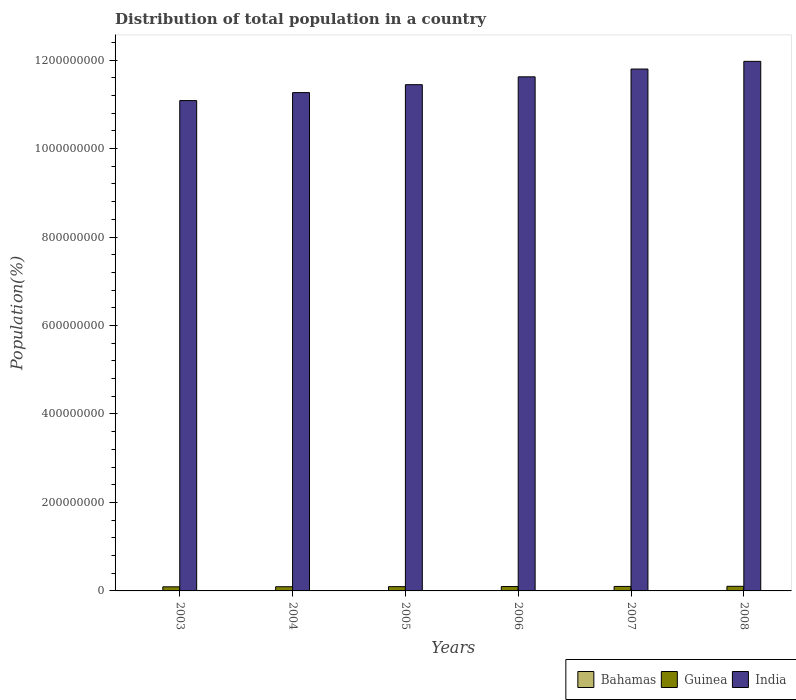How many groups of bars are there?
Your answer should be very brief. 6. Are the number of bars per tick equal to the number of legend labels?
Your answer should be very brief. Yes. How many bars are there on the 3rd tick from the right?
Your answer should be compact. 3. What is the label of the 2nd group of bars from the left?
Provide a short and direct response. 2004. In how many cases, is the number of bars for a given year not equal to the number of legend labels?
Your answer should be compact. 0. What is the population of in Guinea in 2003?
Ensure brevity in your answer.  9.28e+06. Across all years, what is the maximum population of in India?
Your response must be concise. 1.20e+09. Across all years, what is the minimum population of in Guinea?
Provide a short and direct response. 9.28e+06. What is the total population of in Guinea in the graph?
Offer a very short reply. 5.89e+07. What is the difference between the population of in Guinea in 2006 and that in 2007?
Offer a very short reply. -2.54e+05. What is the difference between the population of in India in 2007 and the population of in Bahamas in 2006?
Your answer should be compact. 1.18e+09. What is the average population of in Guinea per year?
Provide a succinct answer. 9.82e+06. In the year 2003, what is the difference between the population of in India and population of in Bahamas?
Your response must be concise. 1.11e+09. In how many years, is the population of in Guinea greater than 320000000 %?
Your response must be concise. 0. What is the ratio of the population of in Guinea in 2006 to that in 2008?
Offer a terse response. 0.95. Is the difference between the population of in India in 2003 and 2006 greater than the difference between the population of in Bahamas in 2003 and 2006?
Give a very brief answer. No. What is the difference between the highest and the second highest population of in Guinea?
Keep it short and to the point. 2.75e+05. What is the difference between the highest and the lowest population of in India?
Give a very brief answer. 8.87e+07. In how many years, is the population of in India greater than the average population of in India taken over all years?
Keep it short and to the point. 3. What does the 3rd bar from the left in 2007 represents?
Provide a short and direct response. India. Is it the case that in every year, the sum of the population of in Bahamas and population of in Guinea is greater than the population of in India?
Keep it short and to the point. No. What is the difference between two consecutive major ticks on the Y-axis?
Make the answer very short. 2.00e+08. Where does the legend appear in the graph?
Make the answer very short. Bottom right. What is the title of the graph?
Your response must be concise. Distribution of total population in a country. What is the label or title of the Y-axis?
Your answer should be very brief. Population(%). What is the Population(%) in Bahamas in 2003?
Your answer should be very brief. 3.16e+05. What is the Population(%) of Guinea in 2003?
Keep it short and to the point. 9.28e+06. What is the Population(%) of India in 2003?
Ensure brevity in your answer.  1.11e+09. What is the Population(%) in Bahamas in 2004?
Your answer should be compact. 3.23e+05. What is the Population(%) of Guinea in 2004?
Offer a very short reply. 9.46e+06. What is the Population(%) of India in 2004?
Make the answer very short. 1.13e+09. What is the Population(%) of Bahamas in 2005?
Ensure brevity in your answer.  3.29e+05. What is the Population(%) in Guinea in 2005?
Provide a short and direct response. 9.67e+06. What is the Population(%) of India in 2005?
Keep it short and to the point. 1.14e+09. What is the Population(%) in Bahamas in 2006?
Provide a succinct answer. 3.36e+05. What is the Population(%) of Guinea in 2006?
Your response must be concise. 9.90e+06. What is the Population(%) of India in 2006?
Offer a very short reply. 1.16e+09. What is the Population(%) in Bahamas in 2007?
Ensure brevity in your answer.  3.42e+05. What is the Population(%) in Guinea in 2007?
Provide a short and direct response. 1.02e+07. What is the Population(%) of India in 2007?
Your answer should be compact. 1.18e+09. What is the Population(%) of Bahamas in 2008?
Your answer should be compact. 3.49e+05. What is the Population(%) of Guinea in 2008?
Keep it short and to the point. 1.04e+07. What is the Population(%) of India in 2008?
Make the answer very short. 1.20e+09. Across all years, what is the maximum Population(%) of Bahamas?
Offer a very short reply. 3.49e+05. Across all years, what is the maximum Population(%) in Guinea?
Offer a very short reply. 1.04e+07. Across all years, what is the maximum Population(%) of India?
Make the answer very short. 1.20e+09. Across all years, what is the minimum Population(%) of Bahamas?
Make the answer very short. 3.16e+05. Across all years, what is the minimum Population(%) in Guinea?
Give a very brief answer. 9.28e+06. Across all years, what is the minimum Population(%) in India?
Your response must be concise. 1.11e+09. What is the total Population(%) in Bahamas in the graph?
Your answer should be compact. 1.99e+06. What is the total Population(%) of Guinea in the graph?
Your answer should be compact. 5.89e+07. What is the total Population(%) in India in the graph?
Make the answer very short. 6.92e+09. What is the difference between the Population(%) of Bahamas in 2003 and that in 2004?
Your answer should be compact. -6782. What is the difference between the Population(%) of Guinea in 2003 and that in 2004?
Your answer should be compact. -1.83e+05. What is the difference between the Population(%) of India in 2003 and that in 2004?
Your answer should be compact. -1.80e+07. What is the difference between the Population(%) in Bahamas in 2003 and that in 2005?
Provide a short and direct response. -1.35e+04. What is the difference between the Population(%) in Guinea in 2003 and that in 2005?
Provide a short and direct response. -3.87e+05. What is the difference between the Population(%) of India in 2003 and that in 2005?
Offer a terse response. -3.60e+07. What is the difference between the Population(%) in Bahamas in 2003 and that in 2006?
Keep it short and to the point. -2.00e+04. What is the difference between the Population(%) of Guinea in 2003 and that in 2006?
Keep it short and to the point. -6.17e+05. What is the difference between the Population(%) in India in 2003 and that in 2006?
Your response must be concise. -5.37e+07. What is the difference between the Population(%) of Bahamas in 2003 and that in 2007?
Make the answer very short. -2.65e+04. What is the difference between the Population(%) in Guinea in 2003 and that in 2007?
Your response must be concise. -8.71e+05. What is the difference between the Population(%) of India in 2003 and that in 2007?
Provide a short and direct response. -7.13e+07. What is the difference between the Population(%) of Bahamas in 2003 and that in 2008?
Your answer should be compact. -3.28e+04. What is the difference between the Population(%) in Guinea in 2003 and that in 2008?
Your answer should be compact. -1.15e+06. What is the difference between the Population(%) of India in 2003 and that in 2008?
Make the answer very short. -8.87e+07. What is the difference between the Population(%) in Bahamas in 2004 and that in 2005?
Offer a terse response. -6704. What is the difference between the Population(%) of Guinea in 2004 and that in 2005?
Offer a terse response. -2.04e+05. What is the difference between the Population(%) in India in 2004 and that in 2005?
Your answer should be compact. -1.79e+07. What is the difference between the Population(%) of Bahamas in 2004 and that in 2006?
Provide a succinct answer. -1.33e+04. What is the difference between the Population(%) of Guinea in 2004 and that in 2006?
Your answer should be very brief. -4.34e+05. What is the difference between the Population(%) of India in 2004 and that in 2006?
Give a very brief answer. -3.57e+07. What is the difference between the Population(%) of Bahamas in 2004 and that in 2007?
Your response must be concise. -1.97e+04. What is the difference between the Population(%) in Guinea in 2004 and that in 2007?
Your response must be concise. -6.88e+05. What is the difference between the Population(%) in India in 2004 and that in 2007?
Ensure brevity in your answer.  -5.33e+07. What is the difference between the Population(%) of Bahamas in 2004 and that in 2008?
Provide a succinct answer. -2.60e+04. What is the difference between the Population(%) of Guinea in 2004 and that in 2008?
Ensure brevity in your answer.  -9.63e+05. What is the difference between the Population(%) in India in 2004 and that in 2008?
Your answer should be compact. -7.07e+07. What is the difference between the Population(%) of Bahamas in 2005 and that in 2006?
Make the answer very short. -6558. What is the difference between the Population(%) of Guinea in 2005 and that in 2006?
Offer a very short reply. -2.29e+05. What is the difference between the Population(%) in India in 2005 and that in 2006?
Ensure brevity in your answer.  -1.78e+07. What is the difference between the Population(%) in Bahamas in 2005 and that in 2007?
Your answer should be very brief. -1.30e+04. What is the difference between the Population(%) in Guinea in 2005 and that in 2007?
Offer a very short reply. -4.83e+05. What is the difference between the Population(%) of India in 2005 and that in 2007?
Provide a succinct answer. -3.54e+07. What is the difference between the Population(%) of Bahamas in 2005 and that in 2008?
Your response must be concise. -1.93e+04. What is the difference between the Population(%) of Guinea in 2005 and that in 2008?
Your answer should be compact. -7.58e+05. What is the difference between the Population(%) of India in 2005 and that in 2008?
Give a very brief answer. -5.27e+07. What is the difference between the Population(%) in Bahamas in 2006 and that in 2007?
Offer a very short reply. -6458. What is the difference between the Population(%) in Guinea in 2006 and that in 2007?
Make the answer very short. -2.54e+05. What is the difference between the Population(%) in India in 2006 and that in 2007?
Offer a terse response. -1.76e+07. What is the difference between the Population(%) in Bahamas in 2006 and that in 2008?
Provide a short and direct response. -1.28e+04. What is the difference between the Population(%) of Guinea in 2006 and that in 2008?
Your answer should be very brief. -5.29e+05. What is the difference between the Population(%) of India in 2006 and that in 2008?
Give a very brief answer. -3.50e+07. What is the difference between the Population(%) in Bahamas in 2007 and that in 2008?
Ensure brevity in your answer.  -6328. What is the difference between the Population(%) in Guinea in 2007 and that in 2008?
Your answer should be compact. -2.75e+05. What is the difference between the Population(%) in India in 2007 and that in 2008?
Your response must be concise. -1.74e+07. What is the difference between the Population(%) of Bahamas in 2003 and the Population(%) of Guinea in 2004?
Offer a terse response. -9.15e+06. What is the difference between the Population(%) in Bahamas in 2003 and the Population(%) in India in 2004?
Ensure brevity in your answer.  -1.13e+09. What is the difference between the Population(%) in Guinea in 2003 and the Population(%) in India in 2004?
Give a very brief answer. -1.12e+09. What is the difference between the Population(%) in Bahamas in 2003 and the Population(%) in Guinea in 2005?
Ensure brevity in your answer.  -9.35e+06. What is the difference between the Population(%) in Bahamas in 2003 and the Population(%) in India in 2005?
Your response must be concise. -1.14e+09. What is the difference between the Population(%) in Guinea in 2003 and the Population(%) in India in 2005?
Offer a terse response. -1.14e+09. What is the difference between the Population(%) in Bahamas in 2003 and the Population(%) in Guinea in 2006?
Your response must be concise. -9.58e+06. What is the difference between the Population(%) of Bahamas in 2003 and the Population(%) of India in 2006?
Give a very brief answer. -1.16e+09. What is the difference between the Population(%) of Guinea in 2003 and the Population(%) of India in 2006?
Your answer should be very brief. -1.15e+09. What is the difference between the Population(%) in Bahamas in 2003 and the Population(%) in Guinea in 2007?
Your response must be concise. -9.84e+06. What is the difference between the Population(%) of Bahamas in 2003 and the Population(%) of India in 2007?
Make the answer very short. -1.18e+09. What is the difference between the Population(%) in Guinea in 2003 and the Population(%) in India in 2007?
Offer a terse response. -1.17e+09. What is the difference between the Population(%) of Bahamas in 2003 and the Population(%) of Guinea in 2008?
Your answer should be very brief. -1.01e+07. What is the difference between the Population(%) of Bahamas in 2003 and the Population(%) of India in 2008?
Give a very brief answer. -1.20e+09. What is the difference between the Population(%) in Guinea in 2003 and the Population(%) in India in 2008?
Your answer should be very brief. -1.19e+09. What is the difference between the Population(%) in Bahamas in 2004 and the Population(%) in Guinea in 2005?
Your response must be concise. -9.35e+06. What is the difference between the Population(%) in Bahamas in 2004 and the Population(%) in India in 2005?
Provide a short and direct response. -1.14e+09. What is the difference between the Population(%) of Guinea in 2004 and the Population(%) of India in 2005?
Provide a short and direct response. -1.13e+09. What is the difference between the Population(%) in Bahamas in 2004 and the Population(%) in Guinea in 2006?
Make the answer very short. -9.58e+06. What is the difference between the Population(%) of Bahamas in 2004 and the Population(%) of India in 2006?
Keep it short and to the point. -1.16e+09. What is the difference between the Population(%) of Guinea in 2004 and the Population(%) of India in 2006?
Provide a succinct answer. -1.15e+09. What is the difference between the Population(%) of Bahamas in 2004 and the Population(%) of Guinea in 2007?
Keep it short and to the point. -9.83e+06. What is the difference between the Population(%) of Bahamas in 2004 and the Population(%) of India in 2007?
Provide a short and direct response. -1.18e+09. What is the difference between the Population(%) in Guinea in 2004 and the Population(%) in India in 2007?
Your response must be concise. -1.17e+09. What is the difference between the Population(%) of Bahamas in 2004 and the Population(%) of Guinea in 2008?
Make the answer very short. -1.01e+07. What is the difference between the Population(%) in Bahamas in 2004 and the Population(%) in India in 2008?
Make the answer very short. -1.20e+09. What is the difference between the Population(%) of Guinea in 2004 and the Population(%) of India in 2008?
Keep it short and to the point. -1.19e+09. What is the difference between the Population(%) of Bahamas in 2005 and the Population(%) of Guinea in 2006?
Your answer should be compact. -9.57e+06. What is the difference between the Population(%) in Bahamas in 2005 and the Population(%) in India in 2006?
Ensure brevity in your answer.  -1.16e+09. What is the difference between the Population(%) in Guinea in 2005 and the Population(%) in India in 2006?
Your response must be concise. -1.15e+09. What is the difference between the Population(%) of Bahamas in 2005 and the Population(%) of Guinea in 2007?
Give a very brief answer. -9.82e+06. What is the difference between the Population(%) in Bahamas in 2005 and the Population(%) in India in 2007?
Provide a succinct answer. -1.18e+09. What is the difference between the Population(%) in Guinea in 2005 and the Population(%) in India in 2007?
Your answer should be very brief. -1.17e+09. What is the difference between the Population(%) of Bahamas in 2005 and the Population(%) of Guinea in 2008?
Your answer should be very brief. -1.01e+07. What is the difference between the Population(%) in Bahamas in 2005 and the Population(%) in India in 2008?
Your answer should be compact. -1.20e+09. What is the difference between the Population(%) of Guinea in 2005 and the Population(%) of India in 2008?
Provide a succinct answer. -1.19e+09. What is the difference between the Population(%) of Bahamas in 2006 and the Population(%) of Guinea in 2007?
Provide a short and direct response. -9.82e+06. What is the difference between the Population(%) of Bahamas in 2006 and the Population(%) of India in 2007?
Make the answer very short. -1.18e+09. What is the difference between the Population(%) of Guinea in 2006 and the Population(%) of India in 2007?
Your answer should be very brief. -1.17e+09. What is the difference between the Population(%) in Bahamas in 2006 and the Population(%) in Guinea in 2008?
Offer a terse response. -1.01e+07. What is the difference between the Population(%) of Bahamas in 2006 and the Population(%) of India in 2008?
Your response must be concise. -1.20e+09. What is the difference between the Population(%) of Guinea in 2006 and the Population(%) of India in 2008?
Your answer should be very brief. -1.19e+09. What is the difference between the Population(%) in Bahamas in 2007 and the Population(%) in Guinea in 2008?
Offer a very short reply. -1.01e+07. What is the difference between the Population(%) in Bahamas in 2007 and the Population(%) in India in 2008?
Give a very brief answer. -1.20e+09. What is the difference between the Population(%) in Guinea in 2007 and the Population(%) in India in 2008?
Give a very brief answer. -1.19e+09. What is the average Population(%) in Bahamas per year?
Your response must be concise. 3.32e+05. What is the average Population(%) in Guinea per year?
Provide a succinct answer. 9.82e+06. What is the average Population(%) of India per year?
Your answer should be very brief. 1.15e+09. In the year 2003, what is the difference between the Population(%) of Bahamas and Population(%) of Guinea?
Your response must be concise. -8.97e+06. In the year 2003, what is the difference between the Population(%) in Bahamas and Population(%) in India?
Keep it short and to the point. -1.11e+09. In the year 2003, what is the difference between the Population(%) of Guinea and Population(%) of India?
Offer a terse response. -1.10e+09. In the year 2004, what is the difference between the Population(%) in Bahamas and Population(%) in Guinea?
Make the answer very short. -9.14e+06. In the year 2004, what is the difference between the Population(%) of Bahamas and Population(%) of India?
Your answer should be compact. -1.13e+09. In the year 2004, what is the difference between the Population(%) of Guinea and Population(%) of India?
Make the answer very short. -1.12e+09. In the year 2005, what is the difference between the Population(%) in Bahamas and Population(%) in Guinea?
Your response must be concise. -9.34e+06. In the year 2005, what is the difference between the Population(%) of Bahamas and Population(%) of India?
Offer a very short reply. -1.14e+09. In the year 2005, what is the difference between the Population(%) in Guinea and Population(%) in India?
Keep it short and to the point. -1.13e+09. In the year 2006, what is the difference between the Population(%) of Bahamas and Population(%) of Guinea?
Your answer should be compact. -9.56e+06. In the year 2006, what is the difference between the Population(%) in Bahamas and Population(%) in India?
Offer a very short reply. -1.16e+09. In the year 2006, what is the difference between the Population(%) of Guinea and Population(%) of India?
Your answer should be very brief. -1.15e+09. In the year 2007, what is the difference between the Population(%) in Bahamas and Population(%) in Guinea?
Make the answer very short. -9.81e+06. In the year 2007, what is the difference between the Population(%) of Bahamas and Population(%) of India?
Provide a succinct answer. -1.18e+09. In the year 2007, what is the difference between the Population(%) in Guinea and Population(%) in India?
Your answer should be compact. -1.17e+09. In the year 2008, what is the difference between the Population(%) in Bahamas and Population(%) in Guinea?
Your answer should be compact. -1.01e+07. In the year 2008, what is the difference between the Population(%) in Bahamas and Population(%) in India?
Give a very brief answer. -1.20e+09. In the year 2008, what is the difference between the Population(%) of Guinea and Population(%) of India?
Provide a succinct answer. -1.19e+09. What is the ratio of the Population(%) of Bahamas in 2003 to that in 2004?
Your response must be concise. 0.98. What is the ratio of the Population(%) of Guinea in 2003 to that in 2004?
Give a very brief answer. 0.98. What is the ratio of the Population(%) in India in 2003 to that in 2004?
Give a very brief answer. 0.98. What is the ratio of the Population(%) in Guinea in 2003 to that in 2005?
Make the answer very short. 0.96. What is the ratio of the Population(%) in India in 2003 to that in 2005?
Provide a succinct answer. 0.97. What is the ratio of the Population(%) in Bahamas in 2003 to that in 2006?
Provide a short and direct response. 0.94. What is the ratio of the Population(%) of Guinea in 2003 to that in 2006?
Make the answer very short. 0.94. What is the ratio of the Population(%) of India in 2003 to that in 2006?
Offer a terse response. 0.95. What is the ratio of the Population(%) of Bahamas in 2003 to that in 2007?
Your response must be concise. 0.92. What is the ratio of the Population(%) of Guinea in 2003 to that in 2007?
Your answer should be compact. 0.91. What is the ratio of the Population(%) in India in 2003 to that in 2007?
Give a very brief answer. 0.94. What is the ratio of the Population(%) of Bahamas in 2003 to that in 2008?
Your response must be concise. 0.91. What is the ratio of the Population(%) of Guinea in 2003 to that in 2008?
Ensure brevity in your answer.  0.89. What is the ratio of the Population(%) of India in 2003 to that in 2008?
Offer a terse response. 0.93. What is the ratio of the Population(%) in Bahamas in 2004 to that in 2005?
Offer a terse response. 0.98. What is the ratio of the Population(%) in Guinea in 2004 to that in 2005?
Provide a short and direct response. 0.98. What is the ratio of the Population(%) of India in 2004 to that in 2005?
Make the answer very short. 0.98. What is the ratio of the Population(%) of Bahamas in 2004 to that in 2006?
Your answer should be compact. 0.96. What is the ratio of the Population(%) in Guinea in 2004 to that in 2006?
Offer a terse response. 0.96. What is the ratio of the Population(%) in India in 2004 to that in 2006?
Your answer should be compact. 0.97. What is the ratio of the Population(%) in Bahamas in 2004 to that in 2007?
Provide a short and direct response. 0.94. What is the ratio of the Population(%) of Guinea in 2004 to that in 2007?
Your answer should be very brief. 0.93. What is the ratio of the Population(%) in India in 2004 to that in 2007?
Provide a short and direct response. 0.95. What is the ratio of the Population(%) of Bahamas in 2004 to that in 2008?
Offer a terse response. 0.93. What is the ratio of the Population(%) of Guinea in 2004 to that in 2008?
Your answer should be compact. 0.91. What is the ratio of the Population(%) in India in 2004 to that in 2008?
Provide a short and direct response. 0.94. What is the ratio of the Population(%) in Bahamas in 2005 to that in 2006?
Offer a very short reply. 0.98. What is the ratio of the Population(%) in Guinea in 2005 to that in 2006?
Give a very brief answer. 0.98. What is the ratio of the Population(%) in India in 2005 to that in 2006?
Your answer should be compact. 0.98. What is the ratio of the Population(%) of Bahamas in 2005 to that in 2007?
Give a very brief answer. 0.96. What is the ratio of the Population(%) in Guinea in 2005 to that in 2007?
Keep it short and to the point. 0.95. What is the ratio of the Population(%) of India in 2005 to that in 2007?
Your answer should be very brief. 0.97. What is the ratio of the Population(%) in Bahamas in 2005 to that in 2008?
Give a very brief answer. 0.94. What is the ratio of the Population(%) of Guinea in 2005 to that in 2008?
Provide a succinct answer. 0.93. What is the ratio of the Population(%) of India in 2005 to that in 2008?
Offer a terse response. 0.96. What is the ratio of the Population(%) of Bahamas in 2006 to that in 2007?
Your response must be concise. 0.98. What is the ratio of the Population(%) of India in 2006 to that in 2007?
Give a very brief answer. 0.99. What is the ratio of the Population(%) of Bahamas in 2006 to that in 2008?
Your answer should be compact. 0.96. What is the ratio of the Population(%) in Guinea in 2006 to that in 2008?
Provide a succinct answer. 0.95. What is the ratio of the Population(%) in India in 2006 to that in 2008?
Make the answer very short. 0.97. What is the ratio of the Population(%) in Bahamas in 2007 to that in 2008?
Your response must be concise. 0.98. What is the ratio of the Population(%) of Guinea in 2007 to that in 2008?
Provide a short and direct response. 0.97. What is the ratio of the Population(%) of India in 2007 to that in 2008?
Your answer should be compact. 0.99. What is the difference between the highest and the second highest Population(%) of Bahamas?
Give a very brief answer. 6328. What is the difference between the highest and the second highest Population(%) of Guinea?
Keep it short and to the point. 2.75e+05. What is the difference between the highest and the second highest Population(%) of India?
Make the answer very short. 1.74e+07. What is the difference between the highest and the lowest Population(%) in Bahamas?
Offer a very short reply. 3.28e+04. What is the difference between the highest and the lowest Population(%) in Guinea?
Offer a very short reply. 1.15e+06. What is the difference between the highest and the lowest Population(%) in India?
Your response must be concise. 8.87e+07. 